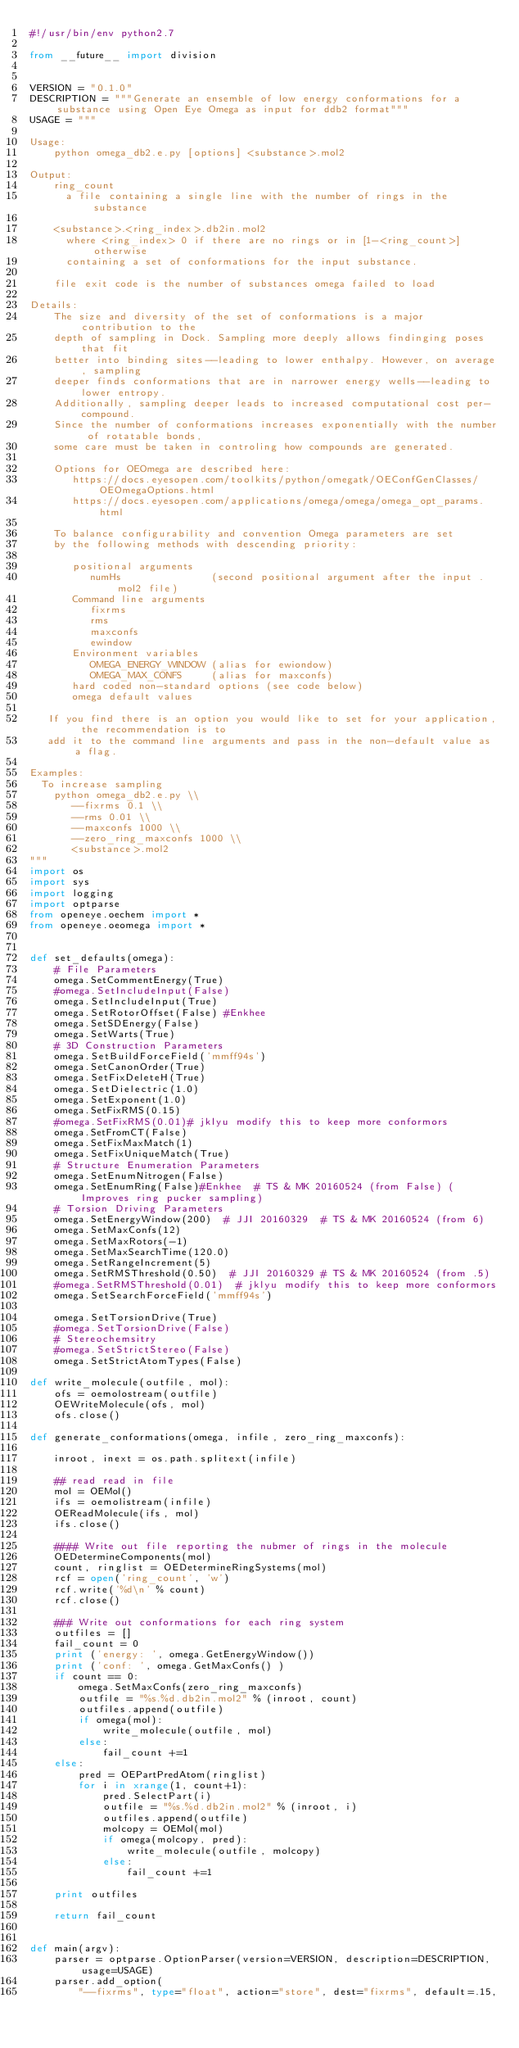<code> <loc_0><loc_0><loc_500><loc_500><_Python_>#!/usr/bin/env python2.7

from __future__ import division


VERSION = "0.1.0"
DESCRIPTION = """Generate an ensemble of low energy conformations for a substance using Open Eye Omega as input for ddb2 format"""
USAGE = """

Usage:
    python omega_db2.e.py [options] <substance>.mol2

Output:
    ring_count
      a file containing a single line with the number of rings in the substance

    <substance>.<ring_index>.db2in.mol2
      where <ring_index> 0 if there are no rings or in [1-<ring_count>] otherwise
      containing a set of conformations for the input substance.

    file exit code is the number of substances omega failed to load

Details:
    The size and diversity of the set of conformations is a major contribution to the
    depth of sampling in Dock. Sampling more deeply allows findinging poses that fit
    better into binding sites--leading to lower enthalpy. However, on average, sampling
    deeper finds conformations that are in narrower energy wells--leading to lower entropy.
    Additionally, sampling deeper leads to increased computational cost per-compound.
    Since the number of conformations increases exponentially with the number of rotatable bonds,
    some care must be taken in controling how compounds are generated.

    Options for OEOmega are described here:
       https://docs.eyesopen.com/toolkits/python/omegatk/OEConfGenClasses/OEOmegaOptions.html
       https://docs.eyesopen.com/applications/omega/omega/omega_opt_params.html

    To balance configurability and convention Omega parameters are set
    by the following methods with descending priority:

       positional arguments
          numHs               (second positional argument after the input .mol2 file)
       Command line arguments
          fixrms
          rms
          maxconfs
          ewindow
       Environment variables
          OMEGA_ENERGY_WINDOW (alias for ewiondow)
          OMEGA_MAX_CONFS     (alias for maxconfs)
       hard coded non-standard options (see code below)
       omega default values

   If you find there is an option you would like to set for your application, the recommendation is to
   add it to the command line arguments and pass in the non-default value as a flag.

Examples:
  To increase sampling
    python omega_db2.e.py \\
       --fixrms 0.1 \\
       --rms 0.01 \\
       --maxconfs 1000 \\
       --zero_ring_maxconfs 1000 \\
       <substance>.mol2
"""
import os
import sys
import logging
import optparse
from openeye.oechem import *
from openeye.oeomega import *


def set_defaults(omega):
    # File Parameters
    omega.SetCommentEnergy(True)
    #omega.SetIncludeInput(False)
    omega.SetIncludeInput(True)
    omega.SetRotorOffset(False) #Enkhee
    omega.SetSDEnergy(False)
    omega.SetWarts(True)
    # 3D Construction Parameters
    omega.SetBuildForceField('mmff94s')
    omega.SetCanonOrder(True)
    omega.SetFixDeleteH(True)
    omega.SetDielectric(1.0)
    omega.SetExponent(1.0)
    omega.SetFixRMS(0.15)
    #omega.SetFixRMS(0.01)# jklyu modify this to keep more conformors
    omega.SetFromCT(False)
    omega.SetFixMaxMatch(1)
    omega.SetFixUniqueMatch(True)
    # Structure Enumeration Parameters
    omega.SetEnumNitrogen(False)
    omega.SetEnumRing(False)#Enkhee  # TS & MK 20160524 (from False) (Improves ring pucker sampling)
    # Torsion Driving Parameters
    omega.SetEnergyWindow(200)  # JJI 20160329  # TS & MK 20160524 (from 6)
    omega.SetMaxConfs(12)
    omega.SetMaxRotors(-1)
    omega.SetMaxSearchTime(120.0)
    omega.SetRangeIncrement(5)
    omega.SetRMSThreshold(0.50)  # JJI 20160329 # TS & MK 20160524 (from .5)
    #omega.SetRMSThreshold(0.01)  # jklyu modify this to keep more conformors
    omega.SetSearchForceField('mmff94s')
    
    omega.SetTorsionDrive(True)
    #omega.SetTorsionDrive(False)
    # Stereochemsitry
    #omega.SetStrictStereo(False)
    omega.SetStrictAtomTypes(False)

def write_molecule(outfile, mol):
    ofs = oemolostream(outfile)
    OEWriteMolecule(ofs, mol)
    ofs.close()

def generate_conformations(omega, infile, zero_ring_maxconfs):

    inroot, inext = os.path.splitext(infile)
    
    ## read read in file
    mol = OEMol()
    ifs = oemolistream(infile)
    OEReadMolecule(ifs, mol)
    ifs.close()

    #### Write out file reporting the nubmer of rings in the molecule
    OEDetermineComponents(mol)
    count, ringlist = OEDetermineRingSystems(mol)
    rcf = open('ring_count', 'w')
    rcf.write('%d\n' % count)
    rcf.close()

    ### Write out conformations for each ring system
    outfiles = []
    fail_count = 0
    print ('energy: ', omega.GetEnergyWindow())
    print ('conf: ', omega.GetMaxConfs() )
    if count == 0:
        omega.SetMaxConfs(zero_ring_maxconfs)
        outfile = "%s.%d.db2in.mol2" % (inroot, count) 
        outfiles.append(outfile)
        if omega(mol):
            write_molecule(outfile, mol)
        else:
            fail_count +=1 
    else:
        pred = OEPartPredAtom(ringlist)
        for i in xrange(1, count+1):
            pred.SelectPart(i)
            outfile = "%s.%d.db2in.mol2" % (inroot, i) 
            outfiles.append(outfile)
            molcopy = OEMol(mol)
            if omega(molcopy, pred):
                write_molecule(outfile, molcopy)
            else:
                fail_count +=1
                
    print outfiles

    return fail_count


def main(argv):
    parser = optparse.OptionParser(version=VERSION, description=DESCRIPTION, usage=USAGE)
    parser.add_option(
        "--fixrms", type="float", action="store", dest="fixrms", default=.15,</code> 